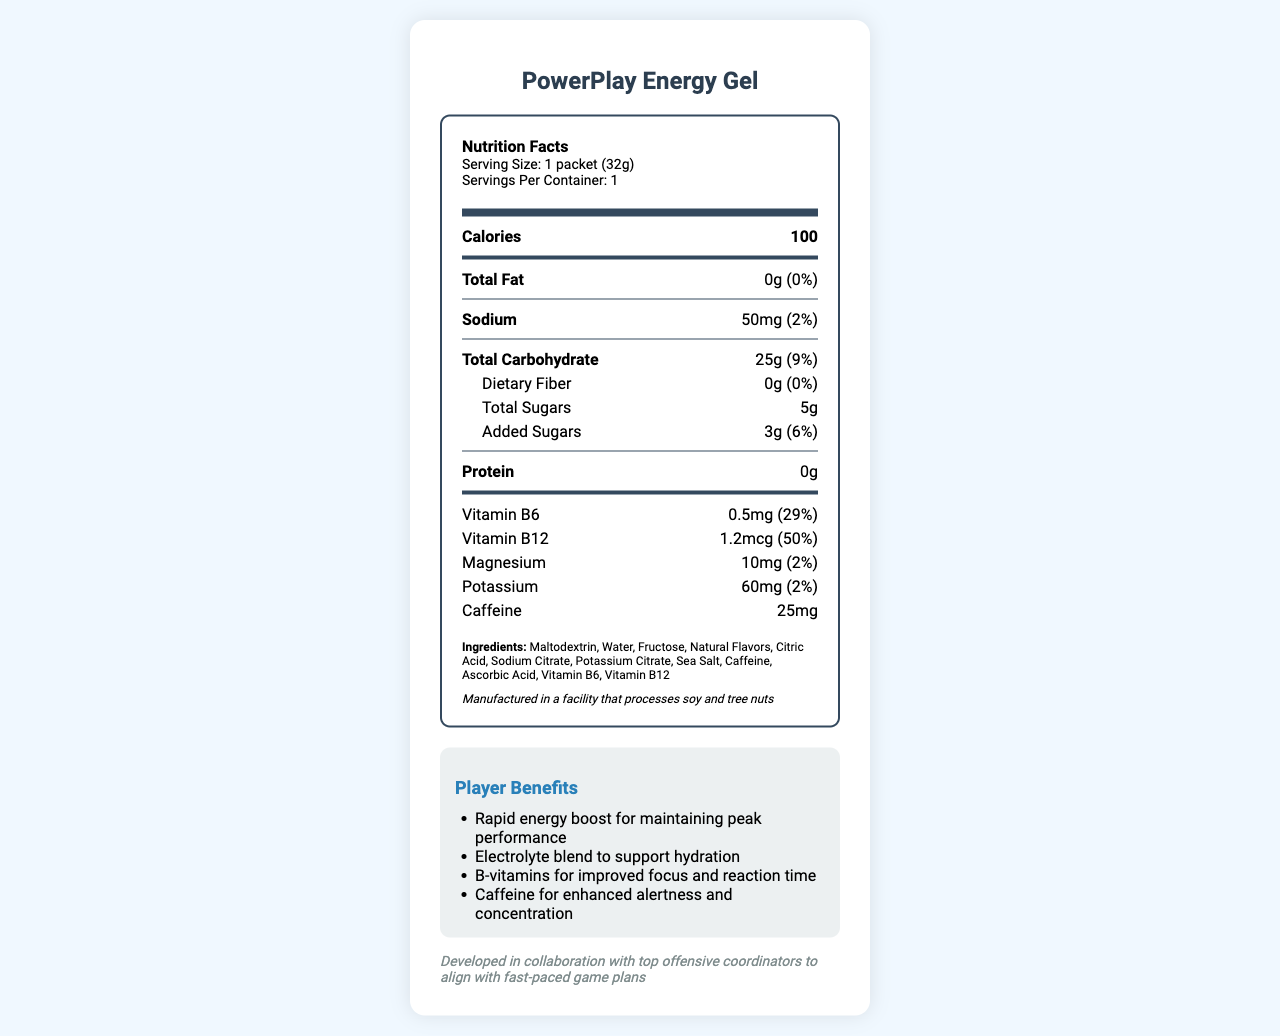what is the serving size? The serving size is listed at the beginning of the nutrition label document.
Answer: 1 packet (32g) how many calories are in one packet of the PowerPlay Energy Gel? The calories are listed immediately after the serving size information.
Answer: 100 what is the amount of sodium in the energy gel? The sodium amount is specified in the nutrient details section.
Answer: 50mg how much added sugar does the energy gel contain? The amount of added sugar is listed under the total carbohydrate section.
Answer: 3g what is the percentage of Daily Value for Vitamin B12? The percentage of daily value for Vitamin B12 is shown directly after its amount in the nutrient list.
Answer: 50% how many vitamins are listed on the label? A. 2 B. 3 C. 4 The vitamins listed are Vitamin B6 and Vitamin B12.
Answer: A what is the flavor of the PowerPlay Energy Gel? A. Citrus Edge B. Berry Blast C. Tropical Burst The flavor is mentioned in the document as "Tropical Burst," near the end.
Answer: C is the energy gel suitable for individuals with soy allergies? The allergen information indicates that the product is manufactured in a facility that processes soy and tree nuts, making it potentially unsuitable for individuals with soy allergies.
Answer: No what is included in the player benefits section? The player benefits section lists these four specific benefits for players consuming the gel.
Answer: Rapid energy boost, Electrolyte blend, B-vitamins, Caffeine summarize the document. The summary encapsulates the key elements of the document, including its purpose, nutritional breakdown, player benefits, and additional information.
Answer: The document provides detailed nutritional and product information about the PowerPlay Energy Gel, a nutrient-dense energy gel used for quick fuel during timeouts. It highlights the serving size, caloric content, nutrient breakdown, ingredients, allergen information, player benefits, team strategy, and flavor. The energy gel offers rapid energy, hydration support, improved focus, and enhanced alertness. what is the percentage of daily value for potassium? The percentage of daily value for potassium is listed after its amount in the nutrient details.
Answer: 2% how often should the energy gel be consumed during a game? The usage instructions specify that it should be consumed during timeouts or breaks in play for quick energy.
Answer: Consume during timeouts or breaks in play what is the total amount of carbohydrates present? The total carbohydrate amount is listed in the nutrient facts section.
Answer: 25g how are the quantities for the vitamins displayed? The quantities for the vitamins are displayed using both the amount (e.g., 1.2mcg) and the percentage of daily value (e.g., 50%).
Answer: Amount and percentage of daily value what is the primary benefit of the caffeine in the energy gel? The player benefits section specifically mentions that caffeine is for enhanced alertness and concentration.
Answer: Enhanced alertness and concentration what is the full list of ingredients? The ingredients are listed in detail in the document.
Answer: Maltodextrin, Water, Fructose, Natural Flavors, Citric Acid, Sodium Citrate, Potassium Citrate, Sea Salt, Caffeine, Ascorbic Acid, Vitamin B6, Vitamin B12 how much protein is in the PowerPlay Energy Gel? The protein content is clearly marked as 0 grams in the nutrient facts section.
Answer: 0g what is the target audience for the PowerPlay Energy Gel? The document does not specifically mention the target audience apart from the benefits for players; we cannot definitively determine the entire scope of its target audience.
Answer: Not enough information 